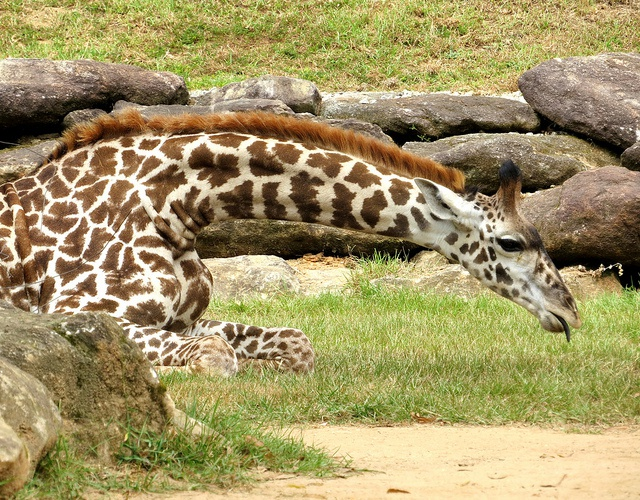Describe the objects in this image and their specific colors. I can see a giraffe in tan, ivory, maroon, and gray tones in this image. 